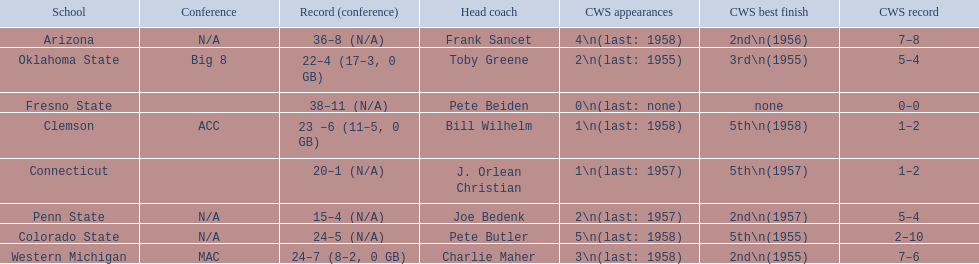What are all the school names? Arizona, Clemson, Colorado State, Connecticut, Fresno State, Oklahoma State, Penn State, Western Michigan. What is the record for each? 36–8 (N/A), 23 –6 (11–5, 0 GB), 24–5 (N/A), 20–1 (N/A), 38–11 (N/A), 22–4 (17–3, 0 GB), 15–4 (N/A), 24–7 (8–2, 0 GB). Which school had the fewest number of wins? Penn State. 